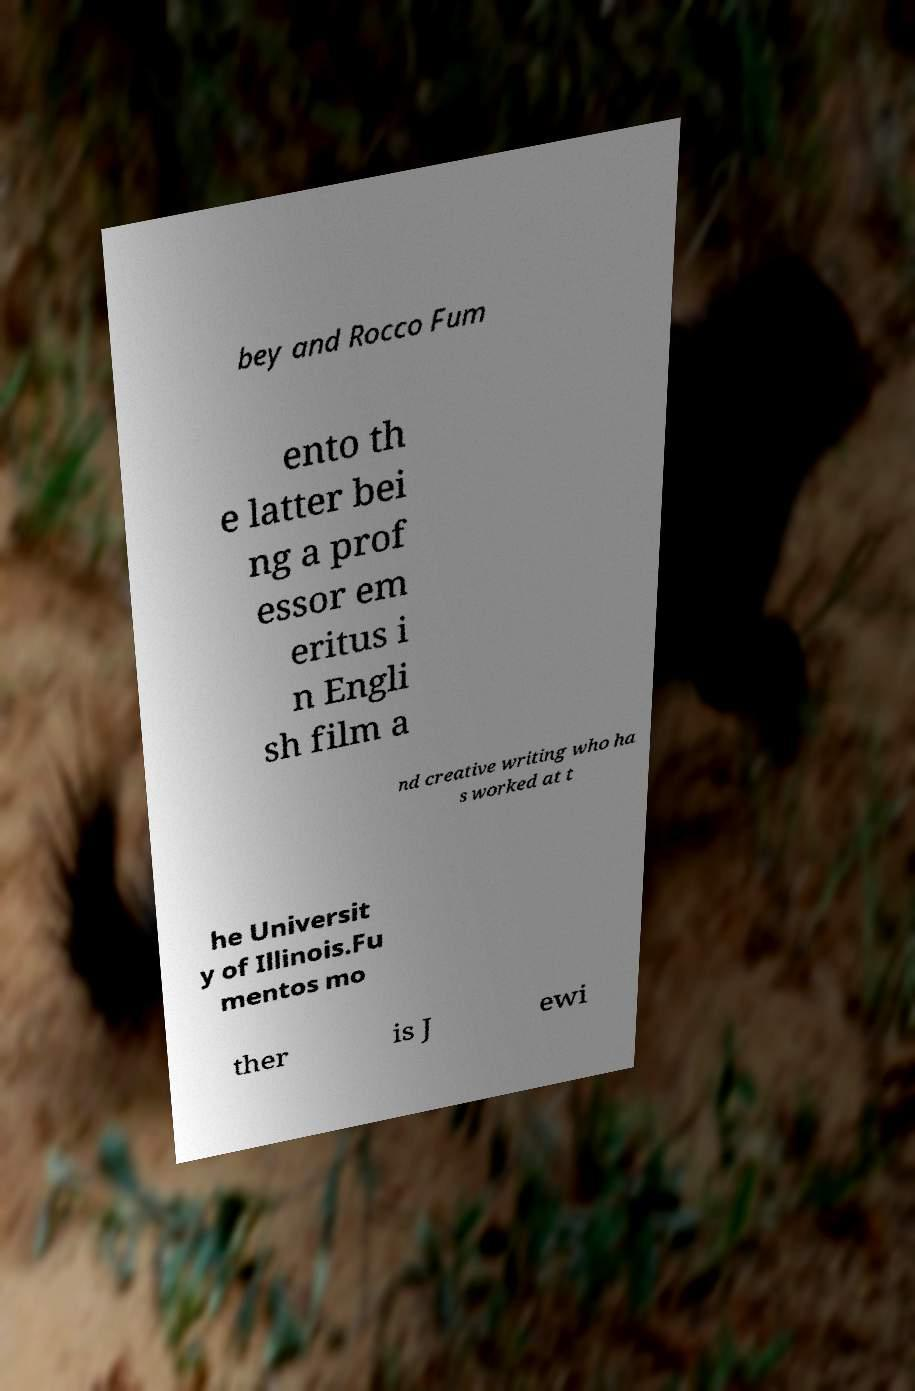Please read and relay the text visible in this image. What does it say? bey and Rocco Fum ento th e latter bei ng a prof essor em eritus i n Engli sh film a nd creative writing who ha s worked at t he Universit y of Illinois.Fu mentos mo ther is J ewi 